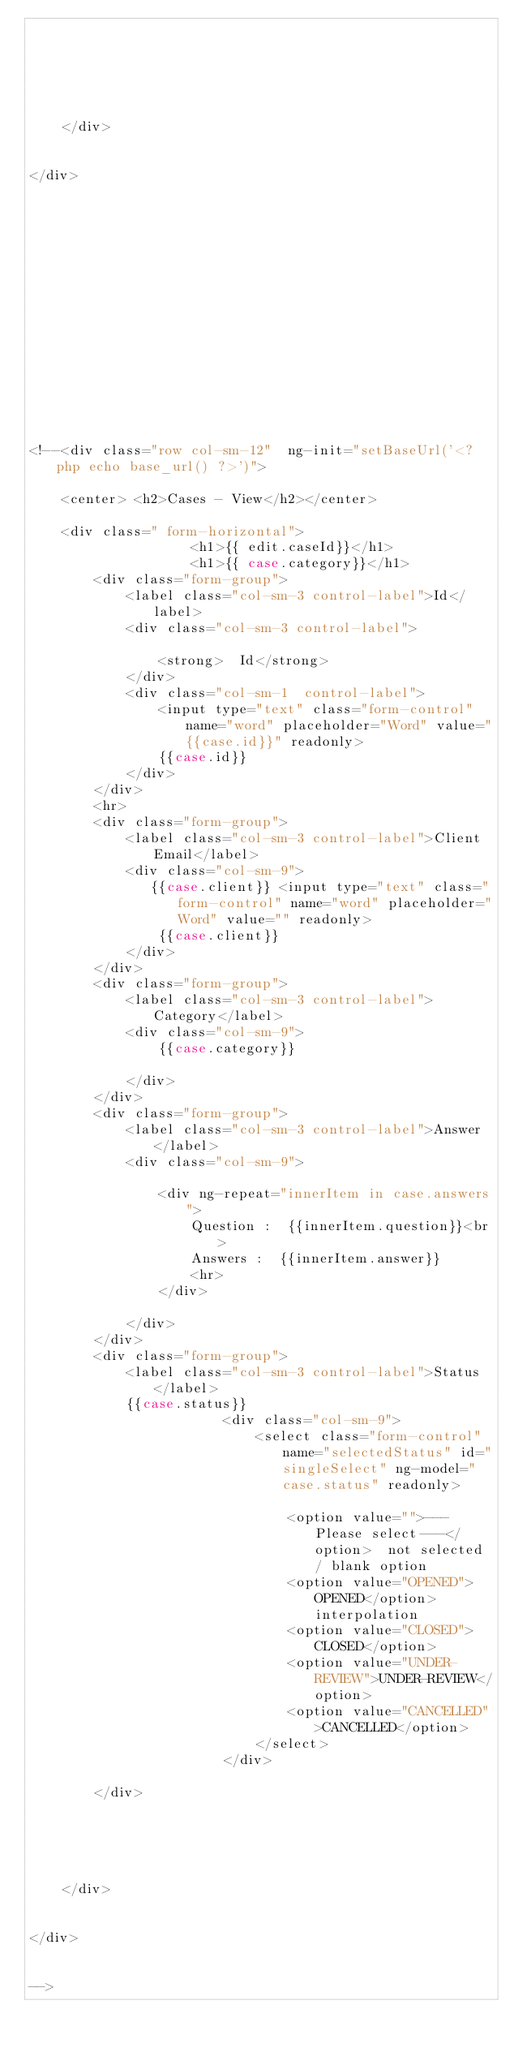<code> <loc_0><loc_0><loc_500><loc_500><_PHP_>





    </div>


</div>
















<!--<div class="row col-sm-12"  ng-init="setBaseUrl('<?php echo base_url() ?>')">

    <center> <h2>Cases - View</h2></center>

    <div class=" form-horizontal">
                    <h1>{{ edit.caseId}}</h1>
                    <h1>{{ case.category}}</h1>
        <div class="form-group">
            <label class="col-sm-3 control-label">Id</label>
            <div class="col-sm-3 control-label">

                <strong>  Id</strong>
            </div>
            <div class="col-sm-1  control-label">
                <input type="text" class="form-control" name="word" placeholder="Word" value="{{case.id}}" readonly>
                {{case.id}}
            </div>
        </div>
        <hr>
        <div class="form-group">
            <label class="col-sm-3 control-label">Client Email</label>
            <div class="col-sm-9">
               {{case.client}} <input type="text" class="form-control" name="word" placeholder="Word" value="" readonly>
                {{case.client}}
            </div>
        </div>
        <div class="form-group">
            <label class="col-sm-3 control-label">Category</label>
            <div class="col-sm-9">
                {{case.category}}

            </div>
        </div>
        <div class="form-group">
            <label class="col-sm-3 control-label">Answer</label>
            <div class="col-sm-9">

                <div ng-repeat="innerItem in case.answers">
                    Question :  {{innerItem.question}}<br>
                    Answers :  {{innerItem.answer}}
                    <hr>
                </div>

            </div>
        </div>
        <div class="form-group">
            <label class="col-sm-3 control-label">Status</label>
            {{case.status}}
                        <div class="col-sm-9">
                            <select class="form-control" name="selectedStatus" id="singleSelect" ng-model="case.status" readonly>

                                <option value="">---Please select---</option>  not selected / blank option
                                <option value="OPENED">OPENED</option>  interpolation
                                <option value="CLOSED">CLOSED</option>
                                <option value="UNDER-REVIEW">UNDER-REVIEW</option>
                                <option value="CANCELLED">CANCELLED</option>
                            </select>
                        </div>

        </div>





    </div>


</div>


-->
</code> 